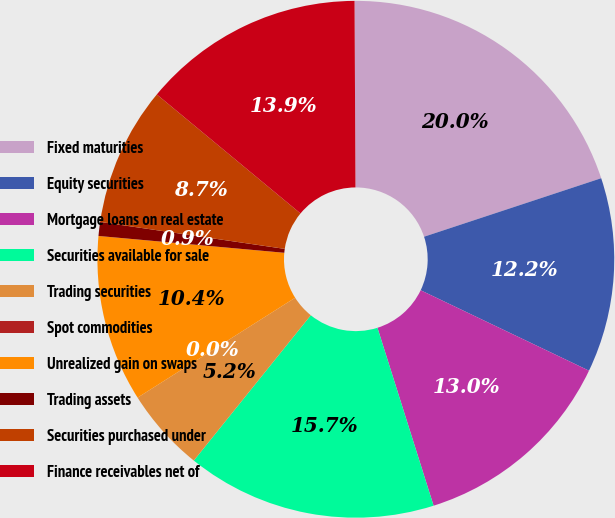<chart> <loc_0><loc_0><loc_500><loc_500><pie_chart><fcel>Fixed maturities<fcel>Equity securities<fcel>Mortgage loans on real estate<fcel>Securities available for sale<fcel>Trading securities<fcel>Spot commodities<fcel>Unrealized gain on swaps<fcel>Trading assets<fcel>Securities purchased under<fcel>Finance receivables net of<nl><fcel>20.0%<fcel>12.17%<fcel>13.04%<fcel>15.65%<fcel>5.22%<fcel>0.0%<fcel>10.43%<fcel>0.87%<fcel>8.7%<fcel>13.91%<nl></chart> 